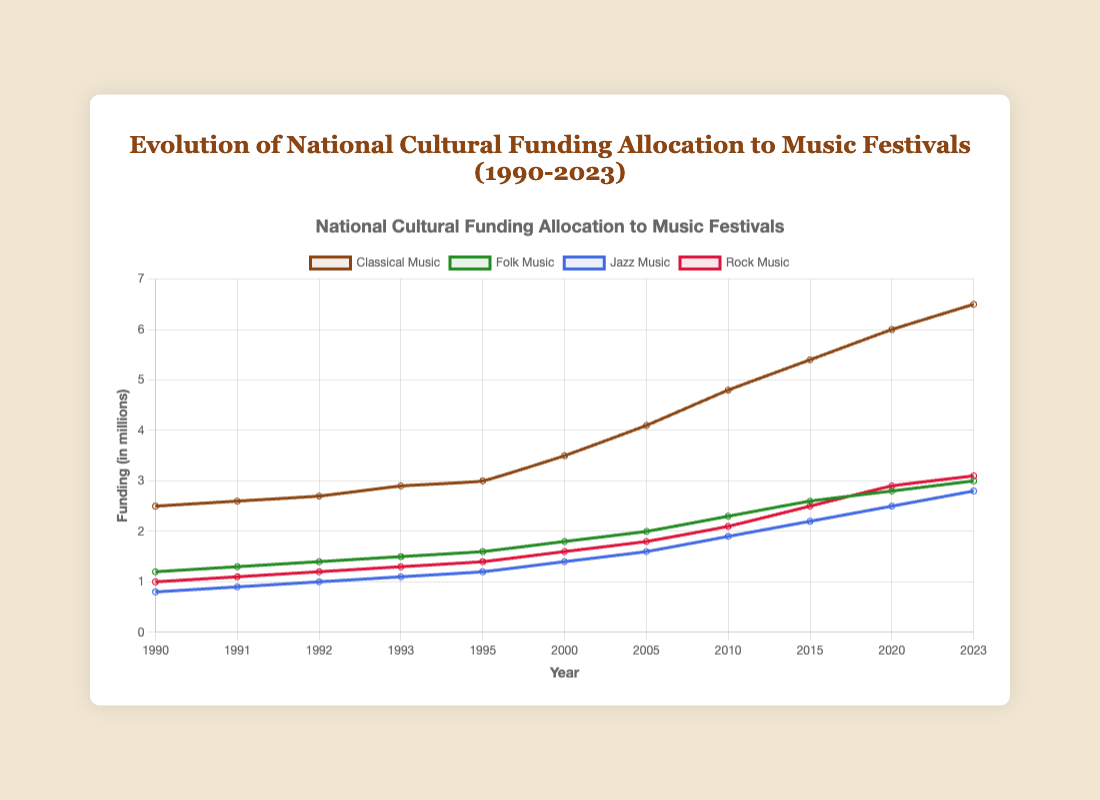What genre received the highest funding in 2023? By looking at the plotted lines for 2023, we can see the highest point among the four genres. The classical music festival funding reaches the highest value.
Answer: Classical Music How much more funding did Rock Music Festivals receive in 2020 compared to 2000? The funding for Rock Music Festivals in 2020 was 2.9 million, while in 2000 it was 1.6 million. The difference can be calculated as 2.9 - 1.6 = 1.3 million.
Answer: 1.3 million Which genre shows the steepest increase in funding from 2005 to 2010? By examining the slopes of the lines between 2005 and 2010, the classical music line rises from 4.1 to 4.8, folk music line from 2.0 to 2.3, jazz music line from 1.6 to 1.9, and rock music line from 1.8 to 2.1. The classical music line shows the steepest increase.
Answer: Classical Music What is the average funding for Jazz Music Festivals between 1990 and 2000? The Jazz Music Festival funding for each year between 1990 and 2000 is: 0.8, 0.9, 1.0, 1.1, 1.2, 1.4. The sum is 6.4, and the average is 6.4 / 6 = 1.07 million.
Answer: 1.07 million What is the total change in funding for Folk Music Festivals from 1990 to 2023? In 1990, the funding for Folk Music Festivals was 1.2 million, and in 2023 it was 3.0 million. The total change is 3.0 - 1.2 = 1.8 million.
Answer: 1.8 million Which year marks the first time Rock Music Festivals funding reached or surpassed 2 million? By following the trend line for Rock Music Festivals, it first reaches 2 million in 2010.
Answer: 2010 Between 1995 and 2000, which genre had the smallest increase in funding? From 1995 to 2000, Classical Music had an increase of 3.0 to 3.5, Folk Music 1.6 to 1.8, Jazz Music 1.2 to 1.4, and Rock Music 1.4 to 1.6. The smallest increase of 0.2 million is in Folk Music.
Answer: Folk Music How does the growth rate in funding for Classical Music compare to that of Jazz Music from 2015 to 2023? The funding for Classical Music increased from 5.4 to 6.5 (an increase of 1.1 million) and Jazz Music increased from 2.2 to 2.8 (an increase of 0.6 million) from 2015 to 2023. This shows that Classical Music had a higher absolute increase in funding.
Answer: Classical Music has a higher growth rate What is the total funding for all music festivals in 2010? Adding the funding for each genre in 2010: Classical Music (4.8) + Folk Music (2.3) + Jazz Music (1.9) + Rock Music (2.1) results in a total of 11.1 million.
Answer: 11.1 million Did the funding for Folk Music Festivals ever surpass the funding for Rock Music Festivals? By examining the plotted lines for Folk and Rock Music festivals over the years, the Folk Music festival funding has consistently tracked below Rock Music festival funding across all years.
Answer: No 